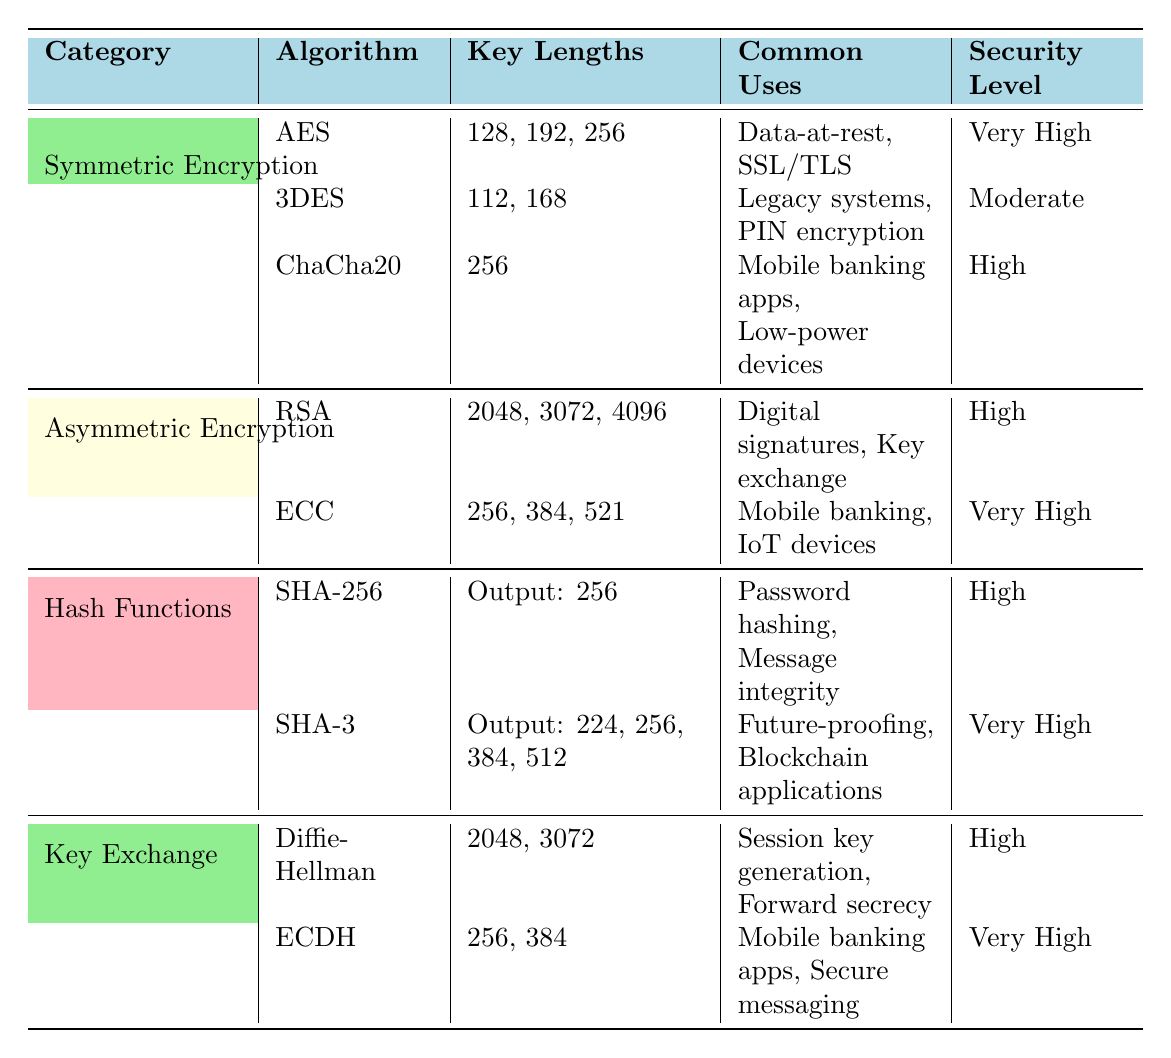What are the key lengths for AES encryption? The table directly shows that the key lengths for AES encryption are 128, 192, and 256 bits.
Answer: 128, 192, 256 Which encryption algorithm has the highest security level? By reviewing the security levels listed in the table, ECC under Asymmetric Encryption and SHA-3 under Hash Functions both have the highest security level marked as "Very High".
Answer: ECC and SHA-3 What are the common uses of ChaCha20 encryption? The table indicates that ChaCha20 is commonly used in mobile banking apps and low-power devices.
Answer: Mobile banking apps, low-power devices Is 3DES considered very high security? The table lists the security level of 3DES as "Moderate," therefore it is not considered very high security.
Answer: No How many different key lengths are used by RSA? The table shows that RSA has three different key lengths: 2048, 3072, and 4096 bits, thus there are three distinct values.
Answer: 3 Which has a higher security level: SHA-256 or Diffie-Hellman? According to the table, SHA-256 has a security level of "High" while Diffie-Hellman also has a security level of "High". Therefore, they are equal in this aspect.
Answer: Equal What is the sum of the security levels of symmetric and asymmetric encryption algorithms in terms of high ratings? Symmetric Encryption has one high (ChaCha20) and one moderate (3DES), whereas Asymmetric has one high (RSA) and one very high (ECC). Therefore, the total high-level counts are 2 for asymmetric and 1 for symmetric, leading to a sum of 2 high ratings from asymmetric encryption.
Answer: 2 List the output sizes for SHA-3. The table specifies that SHA-3 has output sizes of 224, 256, 384, and 512 bits, which can be listed directly from the table.
Answer: 224, 256, 384, 512 How many algorithms in the table use a key length of 256 bits? From the table, AES, ChaCha20, ECC, and ECDH utilize a key length of 256 bits. Counting these shows a total of four algorithms.
Answer: 4 Does any algorithm have output sizes in both 224 and 512 bits? Upon reviewing the table, SHA-3 has output sizes listed as 224, 256, 384, and 512, which confirms that it does have both sizes.
Answer: Yes 